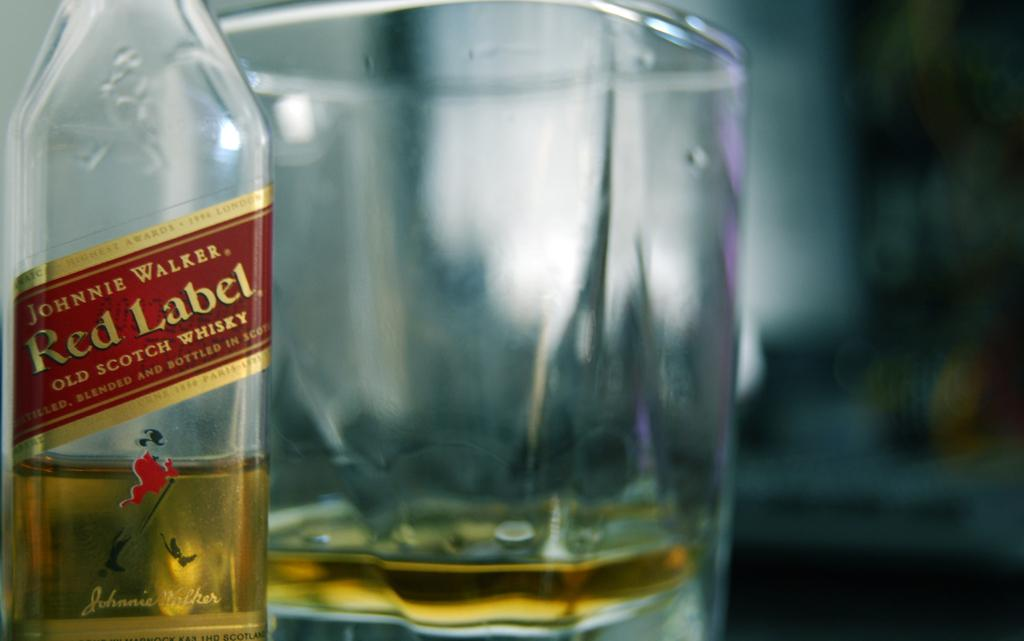What is on the bottle in the image? There is a sticker on the bottle in the image. What is inside the bottle? The bottle contains a drink. What else in the image also contains a drink? There is a glass with a drink in the image. Can you describe the background of the image? The background of the image is blurry. What type of garden can be seen in the background of the image? There is no garden present in the image; the background is blurry. 